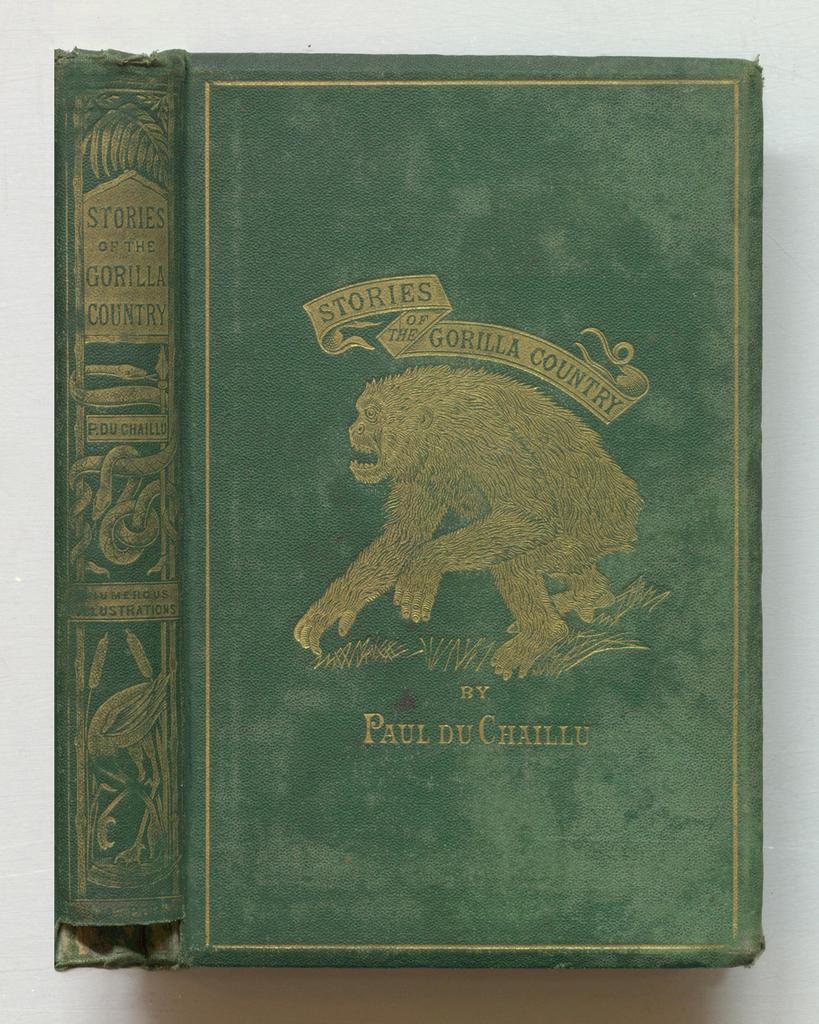What country is the main location of this book?
Your answer should be compact. Gorilla country. Who wrote this book?
Provide a short and direct response. Paul du chaillu. 